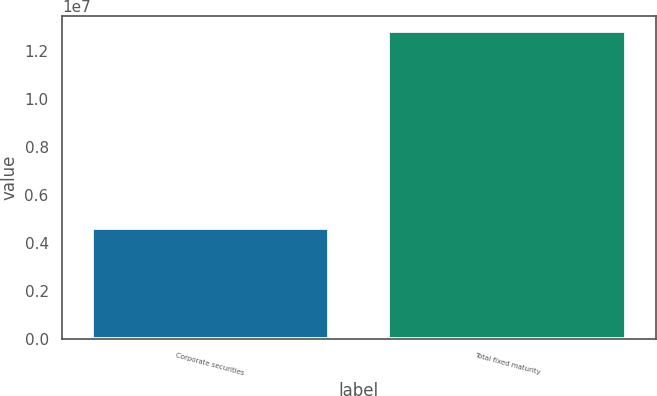Convert chart. <chart><loc_0><loc_0><loc_500><loc_500><bar_chart><fcel>Corporate securities<fcel>Total fixed maturity<nl><fcel>4.626e+06<fcel>1.28312e+07<nl></chart> 